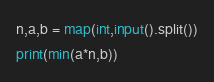<code> <loc_0><loc_0><loc_500><loc_500><_Python_>n,a,b = map(int,input().split())
print(min(a*n,b))
</code> 